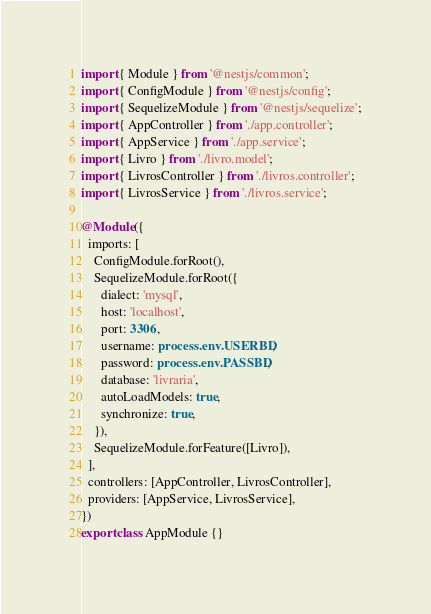Convert code to text. <code><loc_0><loc_0><loc_500><loc_500><_TypeScript_>import { Module } from '@nestjs/common';
import { ConfigModule } from '@nestjs/config';
import { SequelizeModule } from '@nestjs/sequelize';
import { AppController } from './app.controller';
import { AppService } from './app.service';
import { Livro } from './livro.model';
import { LivrosController } from './livros.controller';
import { LivrosService } from './livros.service';

@Module({
  imports: [
    ConfigModule.forRoot(),
    SequelizeModule.forRoot({
      dialect: 'mysql',
      host: 'localhost',
      port: 3306,
      username: process.env.USERBD,
      password: process.env.PASSBD,
      database: 'livraria',
      autoLoadModels: true,
      synchronize: true,
    }),
    SequelizeModule.forFeature([Livro]),
  ],
  controllers: [AppController, LivrosController],
  providers: [AppService, LivrosService],
})
export class AppModule {}
</code> 